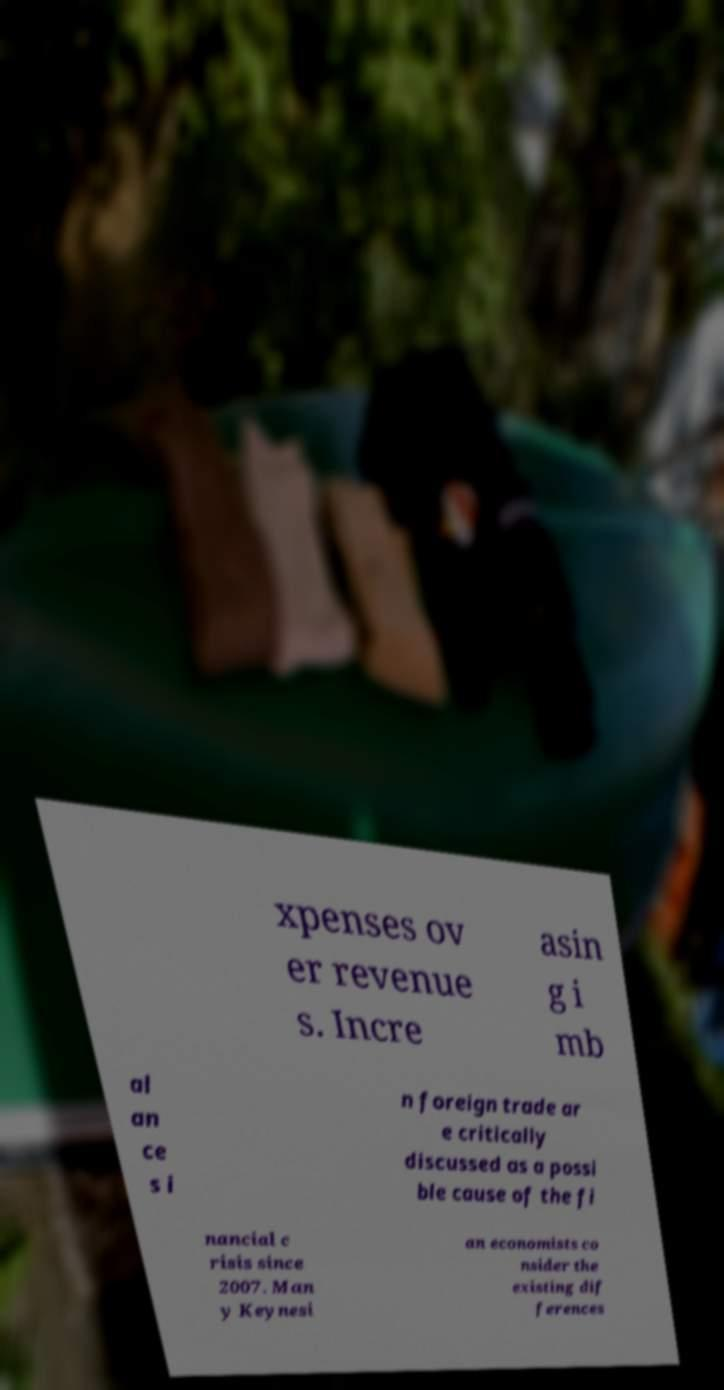Could you extract and type out the text from this image? xpenses ov er revenue s. Incre asin g i mb al an ce s i n foreign trade ar e critically discussed as a possi ble cause of the fi nancial c risis since 2007. Man y Keynesi an economists co nsider the existing dif ferences 